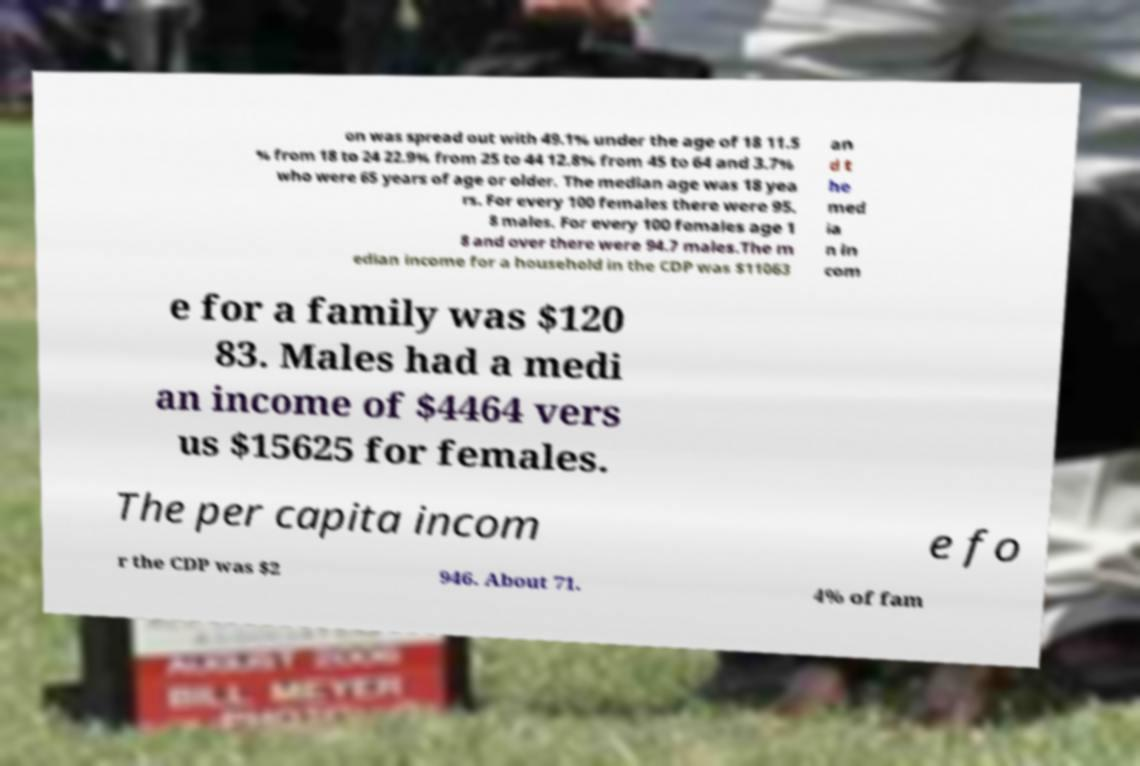Could you assist in decoding the text presented in this image and type it out clearly? on was spread out with 49.1% under the age of 18 11.5 % from 18 to 24 22.9% from 25 to 44 12.8% from 45 to 64 and 3.7% who were 65 years of age or older. The median age was 18 yea rs. For every 100 females there were 95. 8 males. For every 100 females age 1 8 and over there were 94.7 males.The m edian income for a household in the CDP was $11063 an d t he med ia n in com e for a family was $120 83. Males had a medi an income of $4464 vers us $15625 for females. The per capita incom e fo r the CDP was $2 946. About 71. 4% of fam 